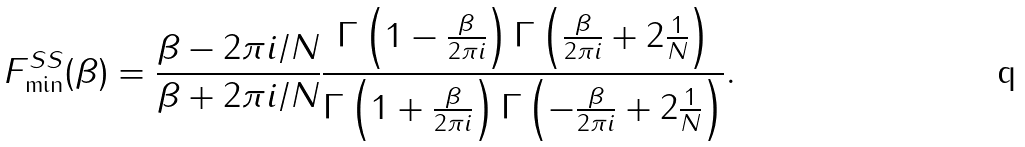<formula> <loc_0><loc_0><loc_500><loc_500>F ^ { S S } _ { \min } ( \beta ) = \frac { \beta - 2 \pi i / N } { \beta + 2 \pi i / N } \frac { \Gamma \left ( 1 - \frac { \beta } { 2 \pi i } \right ) \Gamma \left ( \frac { \beta } { 2 \pi i } + 2 \frac { 1 } { N } \right ) } { \Gamma \left ( 1 + \frac { \beta } { 2 \pi i } \right ) \Gamma \left ( - \frac { \beta } { 2 \pi i } + 2 \frac { 1 } { N } \right ) } .</formula> 